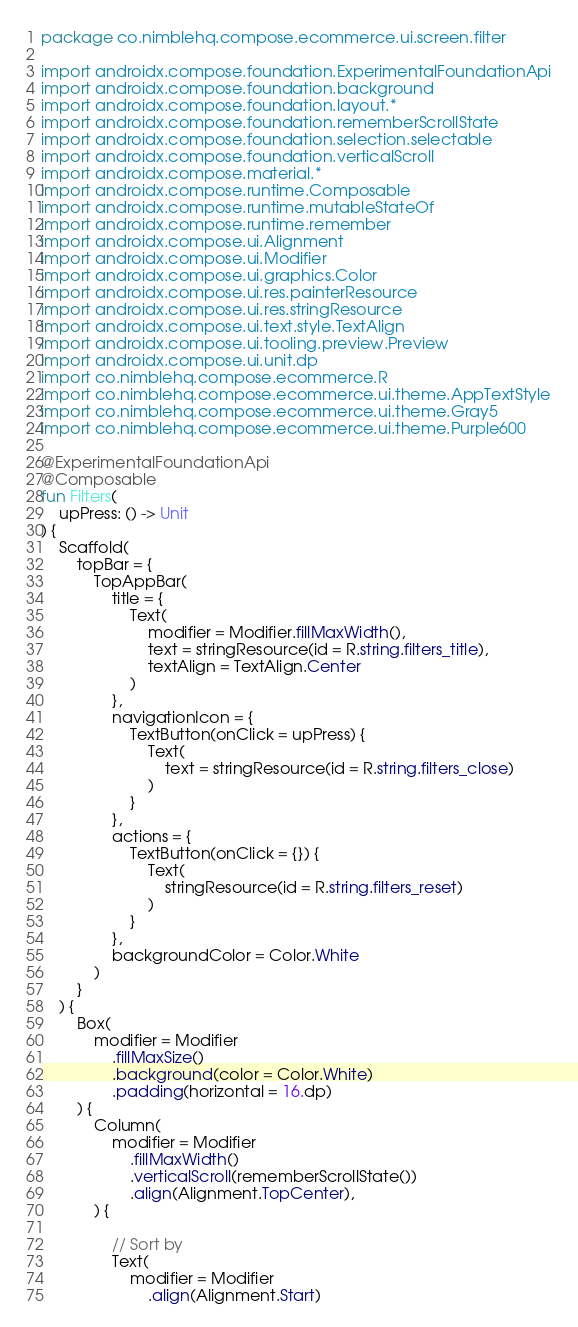Convert code to text. <code><loc_0><loc_0><loc_500><loc_500><_Kotlin_>package co.nimblehq.compose.ecommerce.ui.screen.filter

import androidx.compose.foundation.ExperimentalFoundationApi
import androidx.compose.foundation.background
import androidx.compose.foundation.layout.*
import androidx.compose.foundation.rememberScrollState
import androidx.compose.foundation.selection.selectable
import androidx.compose.foundation.verticalScroll
import androidx.compose.material.*
import androidx.compose.runtime.Composable
import androidx.compose.runtime.mutableStateOf
import androidx.compose.runtime.remember
import androidx.compose.ui.Alignment
import androidx.compose.ui.Modifier
import androidx.compose.ui.graphics.Color
import androidx.compose.ui.res.painterResource
import androidx.compose.ui.res.stringResource
import androidx.compose.ui.text.style.TextAlign
import androidx.compose.ui.tooling.preview.Preview
import androidx.compose.ui.unit.dp
import co.nimblehq.compose.ecommerce.R
import co.nimblehq.compose.ecommerce.ui.theme.AppTextStyle
import co.nimblehq.compose.ecommerce.ui.theme.Gray5
import co.nimblehq.compose.ecommerce.ui.theme.Purple600

@ExperimentalFoundationApi
@Composable
fun Filters(
    upPress: () -> Unit
) {
    Scaffold(
        topBar = {
            TopAppBar(
                title = {
                    Text(
                        modifier = Modifier.fillMaxWidth(),
                        text = stringResource(id = R.string.filters_title),
                        textAlign = TextAlign.Center
                    )
                },
                navigationIcon = {
                    TextButton(onClick = upPress) {
                        Text(
                            text = stringResource(id = R.string.filters_close)
                        )
                    }
                },
                actions = {
                    TextButton(onClick = {}) {
                        Text(
                            stringResource(id = R.string.filters_reset)
                        )
                    }
                },
                backgroundColor = Color.White
            )
        }
    ) {
        Box(
            modifier = Modifier
                .fillMaxSize()
                .background(color = Color.White)
                .padding(horizontal = 16.dp)
        ) {
            Column(
                modifier = Modifier
                    .fillMaxWidth()
                    .verticalScroll(rememberScrollState())
                    .align(Alignment.TopCenter),
            ) {

                // Sort by
                Text(
                    modifier = Modifier
                        .align(Alignment.Start)</code> 